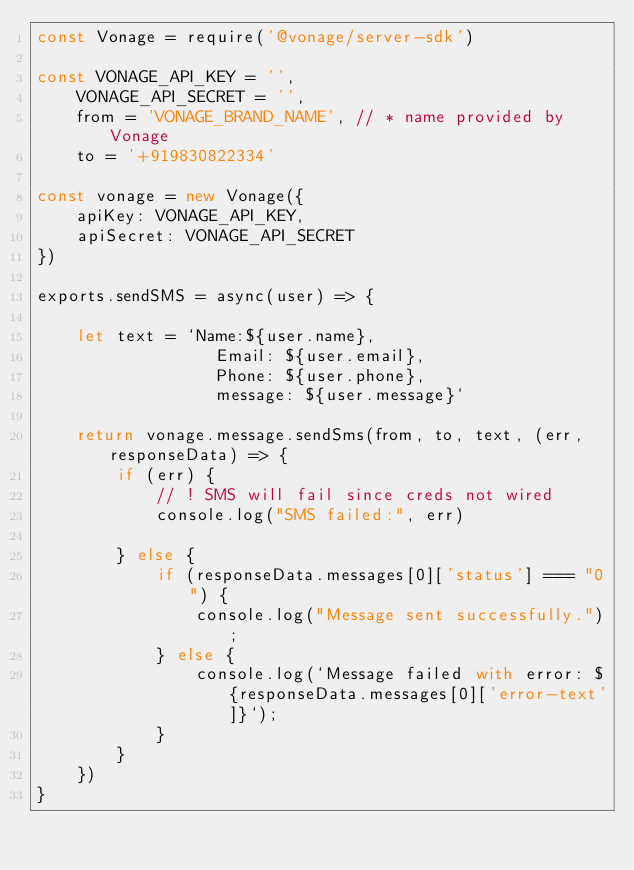<code> <loc_0><loc_0><loc_500><loc_500><_JavaScript_>const Vonage = require('@vonage/server-sdk')

const VONAGE_API_KEY = '',
    VONAGE_API_SECRET = '',
    from = 'VONAGE_BRAND_NAME', // * name provided by Vonage
    to = '+919830822334'

const vonage = new Vonage({
    apiKey: VONAGE_API_KEY,
    apiSecret: VONAGE_API_SECRET
})

exports.sendSMS = async(user) => {

    let text = `Name:${user.name},
                  Email: ${user.email}, 
                  Phone: ${user.phone},
                  message: ${user.message}`

    return vonage.message.sendSms(from, to, text, (err, responseData) => {
        if (err) {
            // ! SMS will fail since creds not wired
            console.log("SMS failed:", err)

        } else {
            if (responseData.messages[0]['status'] === "0") {
                console.log("Message sent successfully.");
            } else {
                console.log(`Message failed with error: ${responseData.messages[0]['error-text']}`);
            }
        }
    })
}</code> 